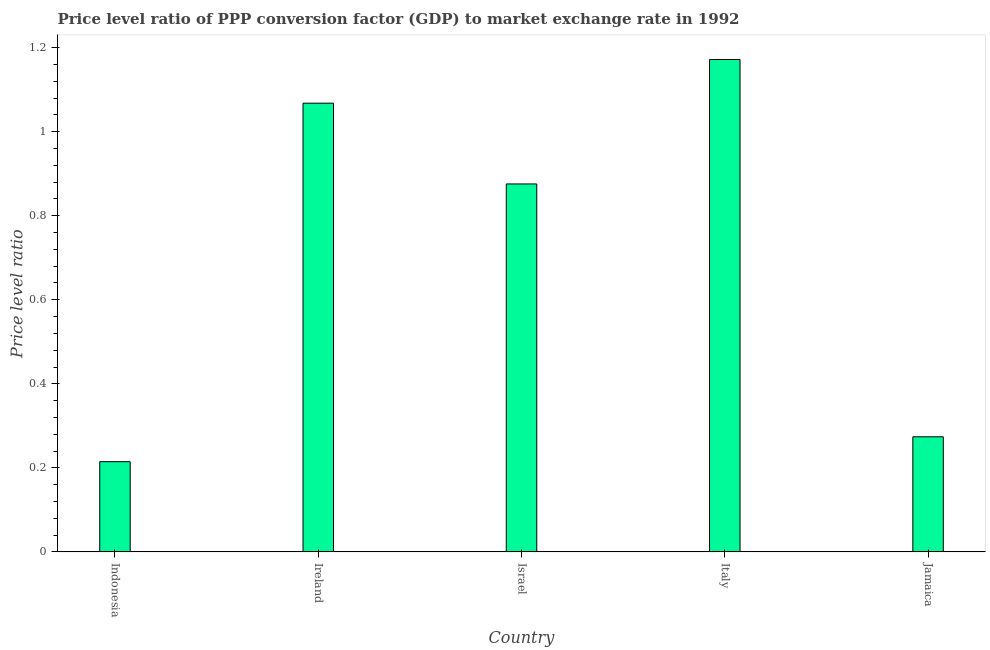Does the graph contain any zero values?
Keep it short and to the point. No. What is the title of the graph?
Your answer should be very brief. Price level ratio of PPP conversion factor (GDP) to market exchange rate in 1992. What is the label or title of the Y-axis?
Offer a terse response. Price level ratio. What is the price level ratio in Italy?
Your response must be concise. 1.17. Across all countries, what is the maximum price level ratio?
Your answer should be very brief. 1.17. Across all countries, what is the minimum price level ratio?
Make the answer very short. 0.21. What is the sum of the price level ratio?
Your answer should be very brief. 3.6. What is the difference between the price level ratio in Israel and Jamaica?
Provide a succinct answer. 0.6. What is the average price level ratio per country?
Ensure brevity in your answer.  0.72. What is the median price level ratio?
Give a very brief answer. 0.88. What is the ratio of the price level ratio in Ireland to that in Israel?
Keep it short and to the point. 1.22. Is the price level ratio in Israel less than that in Jamaica?
Provide a succinct answer. No. What is the difference between the highest and the second highest price level ratio?
Your answer should be very brief. 0.1. What is the difference between the highest and the lowest price level ratio?
Your answer should be very brief. 0.96. In how many countries, is the price level ratio greater than the average price level ratio taken over all countries?
Ensure brevity in your answer.  3. What is the difference between two consecutive major ticks on the Y-axis?
Offer a very short reply. 0.2. What is the Price level ratio of Indonesia?
Ensure brevity in your answer.  0.21. What is the Price level ratio in Ireland?
Make the answer very short. 1.07. What is the Price level ratio in Israel?
Ensure brevity in your answer.  0.88. What is the Price level ratio of Italy?
Give a very brief answer. 1.17. What is the Price level ratio of Jamaica?
Make the answer very short. 0.27. What is the difference between the Price level ratio in Indonesia and Ireland?
Offer a terse response. -0.85. What is the difference between the Price level ratio in Indonesia and Israel?
Provide a succinct answer. -0.66. What is the difference between the Price level ratio in Indonesia and Italy?
Offer a very short reply. -0.96. What is the difference between the Price level ratio in Indonesia and Jamaica?
Give a very brief answer. -0.06. What is the difference between the Price level ratio in Ireland and Israel?
Give a very brief answer. 0.19. What is the difference between the Price level ratio in Ireland and Italy?
Give a very brief answer. -0.1. What is the difference between the Price level ratio in Ireland and Jamaica?
Your answer should be very brief. 0.79. What is the difference between the Price level ratio in Israel and Italy?
Offer a very short reply. -0.3. What is the difference between the Price level ratio in Israel and Jamaica?
Make the answer very short. 0.6. What is the difference between the Price level ratio in Italy and Jamaica?
Offer a very short reply. 0.9. What is the ratio of the Price level ratio in Indonesia to that in Ireland?
Give a very brief answer. 0.2. What is the ratio of the Price level ratio in Indonesia to that in Israel?
Provide a succinct answer. 0.24. What is the ratio of the Price level ratio in Indonesia to that in Italy?
Offer a terse response. 0.18. What is the ratio of the Price level ratio in Indonesia to that in Jamaica?
Your response must be concise. 0.78. What is the ratio of the Price level ratio in Ireland to that in Israel?
Offer a terse response. 1.22. What is the ratio of the Price level ratio in Ireland to that in Italy?
Your answer should be very brief. 0.91. What is the ratio of the Price level ratio in Ireland to that in Jamaica?
Provide a succinct answer. 3.9. What is the ratio of the Price level ratio in Israel to that in Italy?
Make the answer very short. 0.75. What is the ratio of the Price level ratio in Israel to that in Jamaica?
Your answer should be very brief. 3.2. What is the ratio of the Price level ratio in Italy to that in Jamaica?
Ensure brevity in your answer.  4.28. 